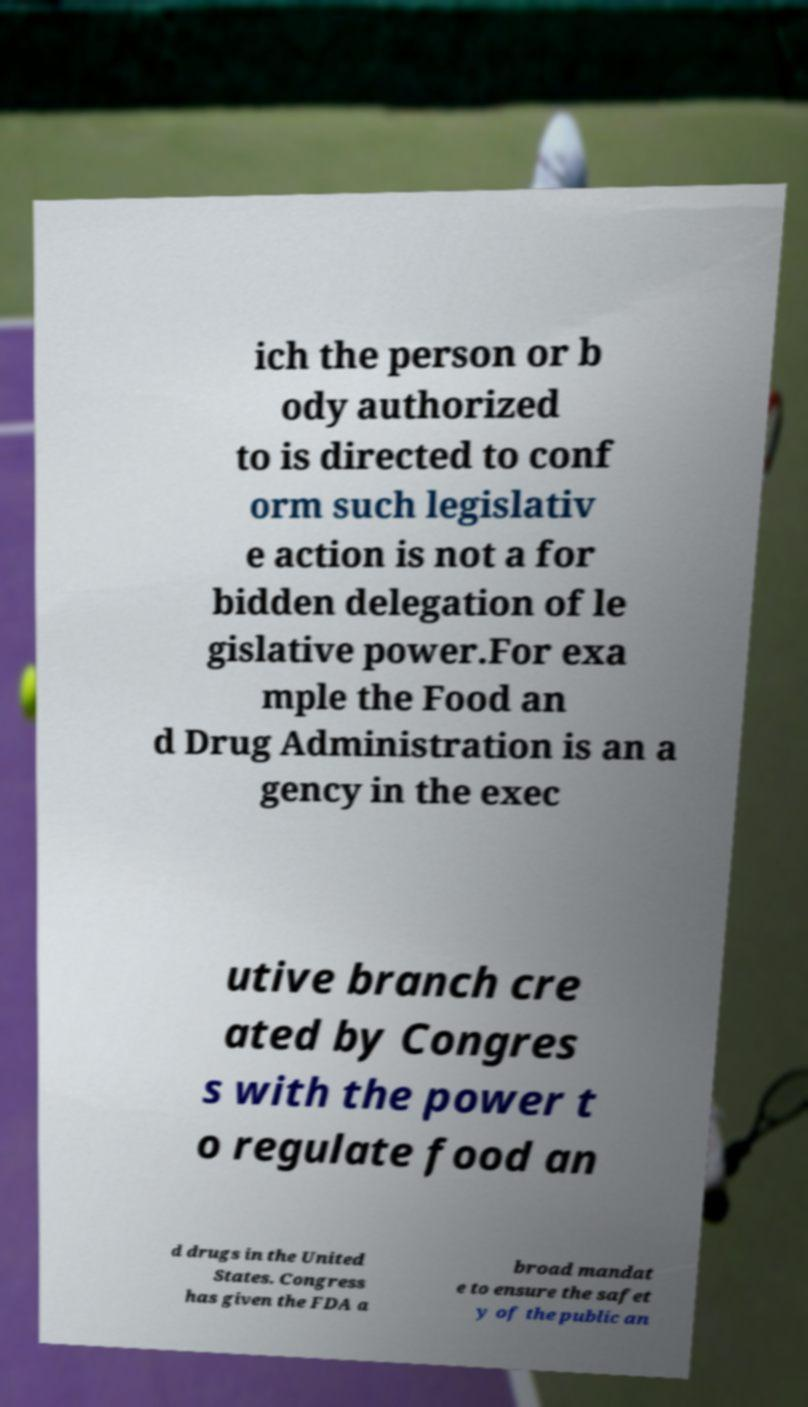For documentation purposes, I need the text within this image transcribed. Could you provide that? ich the person or b ody authorized to is directed to conf orm such legislativ e action is not a for bidden delegation of le gislative power.For exa mple the Food an d Drug Administration is an a gency in the exec utive branch cre ated by Congres s with the power t o regulate food an d drugs in the United States. Congress has given the FDA a broad mandat e to ensure the safet y of the public an 